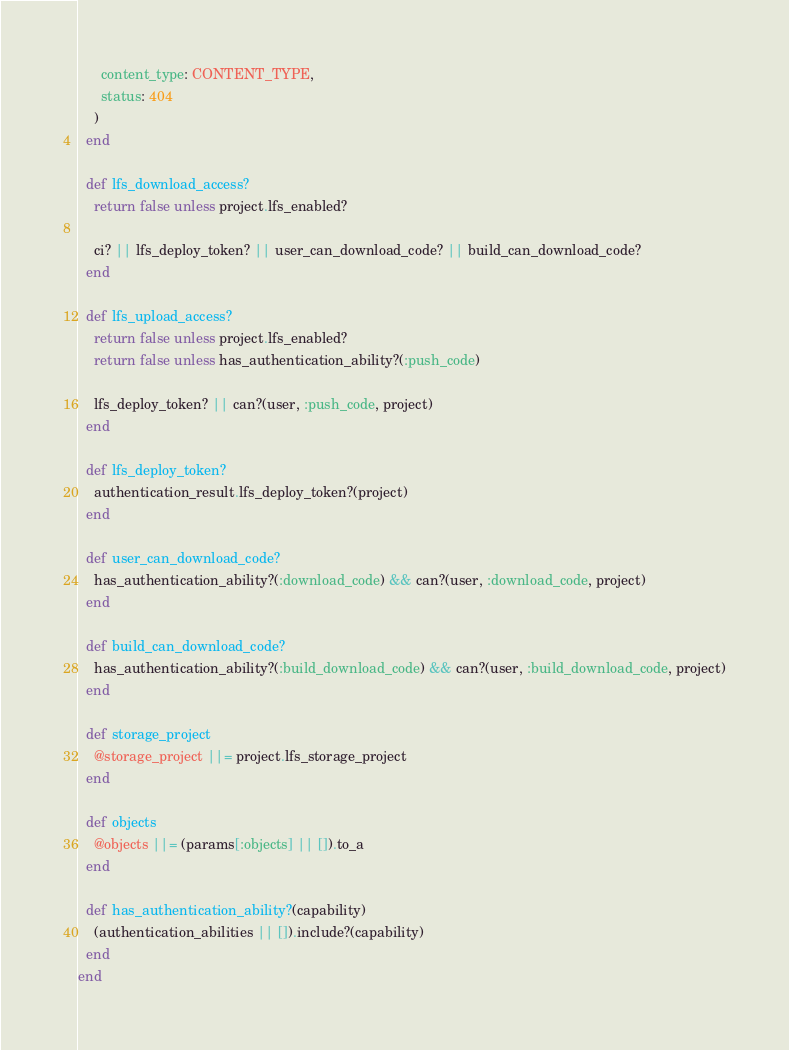<code> <loc_0><loc_0><loc_500><loc_500><_Ruby_>      content_type: CONTENT_TYPE,
      status: 404
    )
  end

  def lfs_download_access?
    return false unless project.lfs_enabled?

    ci? || lfs_deploy_token? || user_can_download_code? || build_can_download_code?
  end

  def lfs_upload_access?
    return false unless project.lfs_enabled?
    return false unless has_authentication_ability?(:push_code)

    lfs_deploy_token? || can?(user, :push_code, project)
  end

  def lfs_deploy_token?
    authentication_result.lfs_deploy_token?(project)
  end

  def user_can_download_code?
    has_authentication_ability?(:download_code) && can?(user, :download_code, project)
  end

  def build_can_download_code?
    has_authentication_ability?(:build_download_code) && can?(user, :build_download_code, project)
  end

  def storage_project
    @storage_project ||= project.lfs_storage_project
  end

  def objects
    @objects ||= (params[:objects] || []).to_a
  end

  def has_authentication_ability?(capability)
    (authentication_abilities || []).include?(capability)
  end
end
</code> 